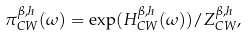Convert formula to latex. <formula><loc_0><loc_0><loc_500><loc_500>\pi _ { C W } ^ { \beta , h } ( \omega ) = \exp ( H _ { C W } ^ { \beta , h } ( \omega ) ) / Z _ { C W } ^ { \beta , h } ,</formula> 